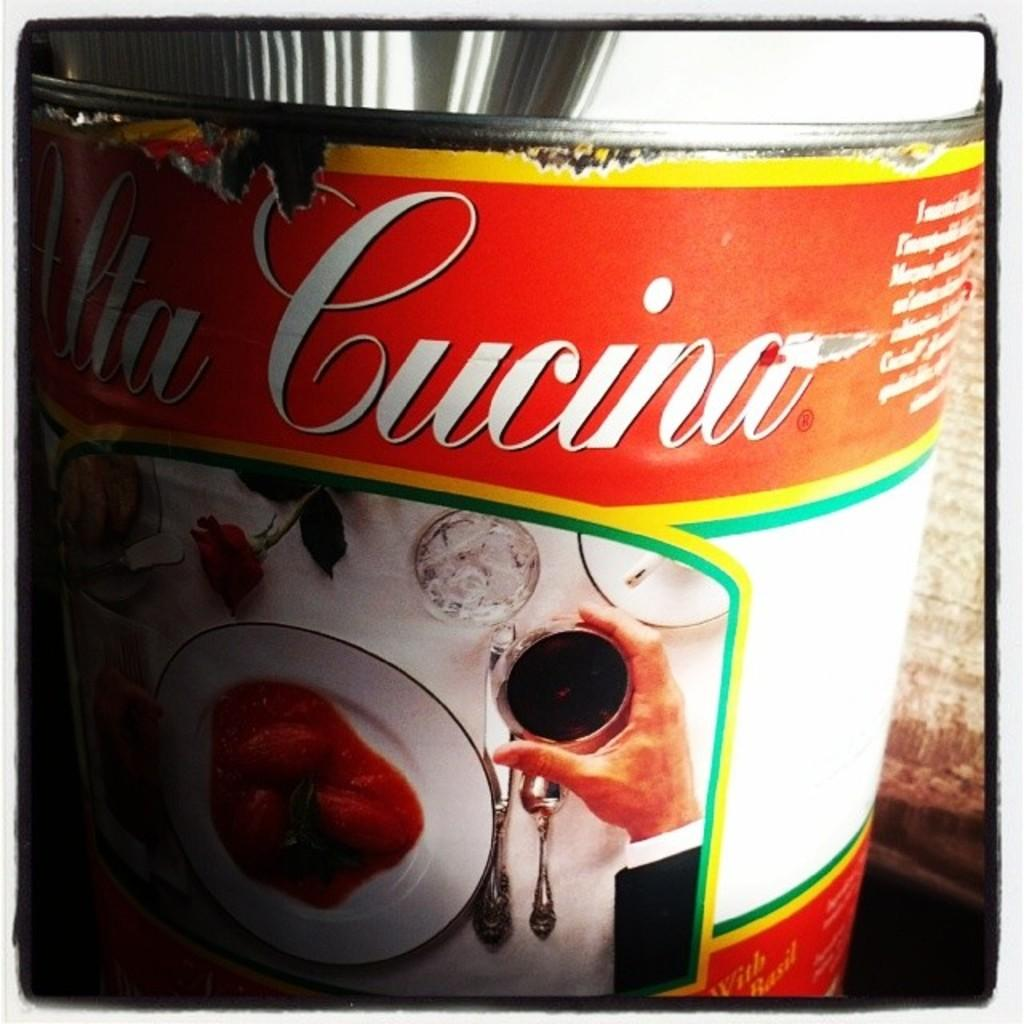<image>
Write a terse but informative summary of the picture. A can of Cucina tomatoes shows them on a plate on the label. 